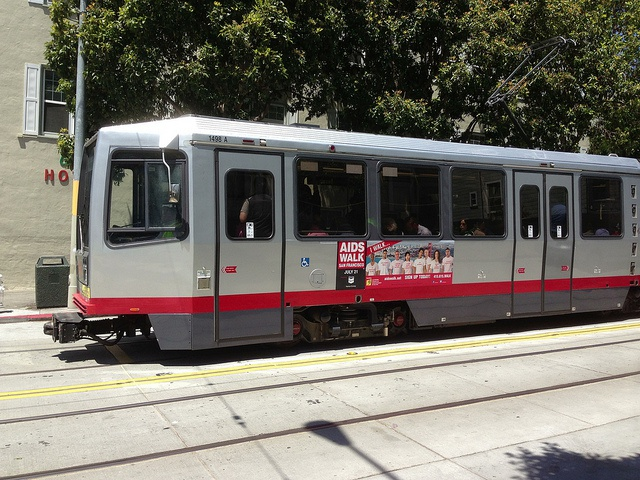Describe the objects in this image and their specific colors. I can see train in darkgray, black, gray, and white tones and people in darkgray, black, and gray tones in this image. 